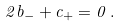Convert formula to latex. <formula><loc_0><loc_0><loc_500><loc_500>2 { b _ { - } } + { c _ { + } } = 0 \, .</formula> 